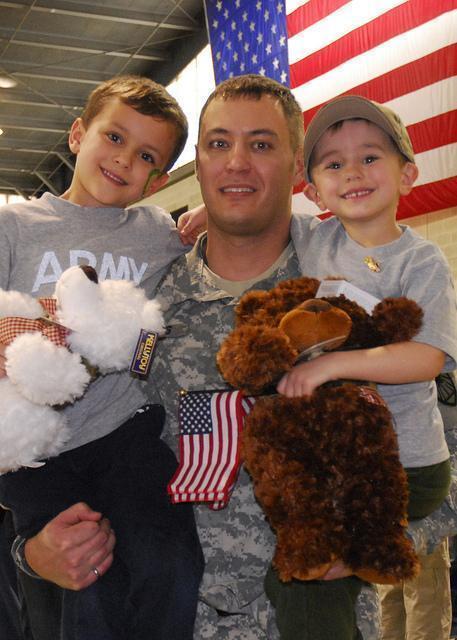What is the man's job?
From the following set of four choices, select the accurate answer to respond to the question.
Options: Soldier, waiter, electrician, dancer. Soldier. 